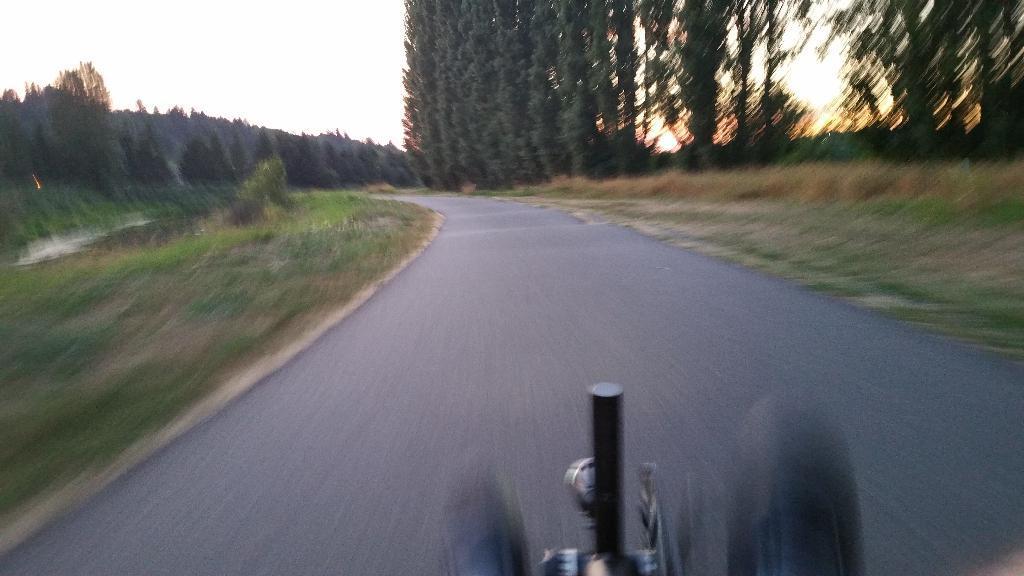Describe this image in one or two sentences. At the bottom of the picture, we see a bicycle or a vehicle. In the middle, we see the road. On either side of the road, we see the grass and the trees. There are trees in the background. At the top, we see the sky and the sun. 